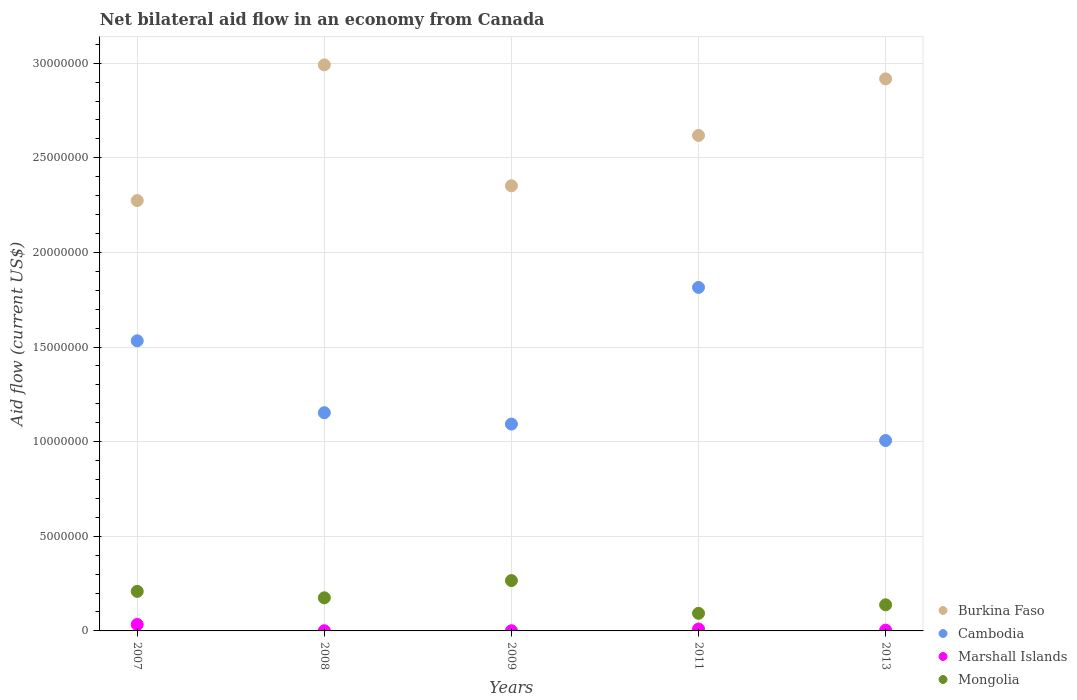What is the net bilateral aid flow in Burkina Faso in 2008?
Offer a very short reply. 2.99e+07. Across all years, what is the minimum net bilateral aid flow in Burkina Faso?
Your answer should be compact. 2.27e+07. In which year was the net bilateral aid flow in Mongolia maximum?
Your answer should be very brief. 2009. In which year was the net bilateral aid flow in Burkina Faso minimum?
Your answer should be compact. 2007. What is the total net bilateral aid flow in Marshall Islands in the graph?
Keep it short and to the point. 5.00e+05. What is the difference between the net bilateral aid flow in Marshall Islands in 2009 and that in 2013?
Give a very brief answer. -3.00e+04. What is the difference between the net bilateral aid flow in Cambodia in 2013 and the net bilateral aid flow in Mongolia in 2008?
Give a very brief answer. 8.31e+06. What is the average net bilateral aid flow in Cambodia per year?
Provide a succinct answer. 1.32e+07. In the year 2011, what is the difference between the net bilateral aid flow in Mongolia and net bilateral aid flow in Burkina Faso?
Your response must be concise. -2.52e+07. Is the net bilateral aid flow in Burkina Faso in 2007 less than that in 2009?
Keep it short and to the point. Yes. What is the difference between the highest and the second highest net bilateral aid flow in Mongolia?
Make the answer very short. 5.70e+05. What is the difference between the highest and the lowest net bilateral aid flow in Cambodia?
Make the answer very short. 8.09e+06. Is it the case that in every year, the sum of the net bilateral aid flow in Cambodia and net bilateral aid flow in Burkina Faso  is greater than the net bilateral aid flow in Marshall Islands?
Your answer should be compact. Yes. Does the net bilateral aid flow in Burkina Faso monotonically increase over the years?
Provide a succinct answer. No. How many dotlines are there?
Offer a very short reply. 4. How many years are there in the graph?
Make the answer very short. 5. Are the values on the major ticks of Y-axis written in scientific E-notation?
Provide a succinct answer. No. Where does the legend appear in the graph?
Your answer should be very brief. Bottom right. How many legend labels are there?
Your response must be concise. 4. How are the legend labels stacked?
Keep it short and to the point. Vertical. What is the title of the graph?
Provide a succinct answer. Net bilateral aid flow in an economy from Canada. Does "Bahamas" appear as one of the legend labels in the graph?
Your answer should be compact. No. What is the Aid flow (current US$) in Burkina Faso in 2007?
Keep it short and to the point. 2.27e+07. What is the Aid flow (current US$) of Cambodia in 2007?
Your answer should be compact. 1.53e+07. What is the Aid flow (current US$) in Mongolia in 2007?
Make the answer very short. 2.09e+06. What is the Aid flow (current US$) of Burkina Faso in 2008?
Offer a terse response. 2.99e+07. What is the Aid flow (current US$) in Cambodia in 2008?
Give a very brief answer. 1.15e+07. What is the Aid flow (current US$) in Marshall Islands in 2008?
Your response must be concise. 10000. What is the Aid flow (current US$) of Mongolia in 2008?
Offer a very short reply. 1.75e+06. What is the Aid flow (current US$) of Burkina Faso in 2009?
Offer a very short reply. 2.35e+07. What is the Aid flow (current US$) in Cambodia in 2009?
Your answer should be very brief. 1.09e+07. What is the Aid flow (current US$) of Mongolia in 2009?
Your answer should be very brief. 2.66e+06. What is the Aid flow (current US$) in Burkina Faso in 2011?
Offer a very short reply. 2.62e+07. What is the Aid flow (current US$) in Cambodia in 2011?
Offer a very short reply. 1.82e+07. What is the Aid flow (current US$) of Mongolia in 2011?
Provide a short and direct response. 9.30e+05. What is the Aid flow (current US$) of Burkina Faso in 2013?
Provide a succinct answer. 2.92e+07. What is the Aid flow (current US$) of Cambodia in 2013?
Ensure brevity in your answer.  1.01e+07. What is the Aid flow (current US$) of Marshall Islands in 2013?
Keep it short and to the point. 4.00e+04. What is the Aid flow (current US$) in Mongolia in 2013?
Offer a terse response. 1.38e+06. Across all years, what is the maximum Aid flow (current US$) of Burkina Faso?
Offer a terse response. 2.99e+07. Across all years, what is the maximum Aid flow (current US$) of Cambodia?
Give a very brief answer. 1.82e+07. Across all years, what is the maximum Aid flow (current US$) of Mongolia?
Provide a short and direct response. 2.66e+06. Across all years, what is the minimum Aid flow (current US$) in Burkina Faso?
Make the answer very short. 2.27e+07. Across all years, what is the minimum Aid flow (current US$) of Cambodia?
Your answer should be very brief. 1.01e+07. Across all years, what is the minimum Aid flow (current US$) of Marshall Islands?
Offer a very short reply. 10000. Across all years, what is the minimum Aid flow (current US$) of Mongolia?
Offer a very short reply. 9.30e+05. What is the total Aid flow (current US$) in Burkina Faso in the graph?
Your answer should be very brief. 1.32e+08. What is the total Aid flow (current US$) in Cambodia in the graph?
Your answer should be compact. 6.60e+07. What is the total Aid flow (current US$) of Mongolia in the graph?
Provide a succinct answer. 8.81e+06. What is the difference between the Aid flow (current US$) of Burkina Faso in 2007 and that in 2008?
Your response must be concise. -7.17e+06. What is the difference between the Aid flow (current US$) in Cambodia in 2007 and that in 2008?
Ensure brevity in your answer.  3.80e+06. What is the difference between the Aid flow (current US$) of Marshall Islands in 2007 and that in 2008?
Make the answer very short. 3.30e+05. What is the difference between the Aid flow (current US$) of Burkina Faso in 2007 and that in 2009?
Give a very brief answer. -7.80e+05. What is the difference between the Aid flow (current US$) of Cambodia in 2007 and that in 2009?
Provide a succinct answer. 4.40e+06. What is the difference between the Aid flow (current US$) in Mongolia in 2007 and that in 2009?
Make the answer very short. -5.70e+05. What is the difference between the Aid flow (current US$) of Burkina Faso in 2007 and that in 2011?
Your response must be concise. -3.44e+06. What is the difference between the Aid flow (current US$) of Cambodia in 2007 and that in 2011?
Your answer should be very brief. -2.82e+06. What is the difference between the Aid flow (current US$) of Marshall Islands in 2007 and that in 2011?
Provide a short and direct response. 2.40e+05. What is the difference between the Aid flow (current US$) in Mongolia in 2007 and that in 2011?
Give a very brief answer. 1.16e+06. What is the difference between the Aid flow (current US$) of Burkina Faso in 2007 and that in 2013?
Offer a very short reply. -6.43e+06. What is the difference between the Aid flow (current US$) in Cambodia in 2007 and that in 2013?
Offer a very short reply. 5.27e+06. What is the difference between the Aid flow (current US$) of Mongolia in 2007 and that in 2013?
Your answer should be very brief. 7.10e+05. What is the difference between the Aid flow (current US$) of Burkina Faso in 2008 and that in 2009?
Provide a short and direct response. 6.39e+06. What is the difference between the Aid flow (current US$) in Marshall Islands in 2008 and that in 2009?
Offer a terse response. 0. What is the difference between the Aid flow (current US$) in Mongolia in 2008 and that in 2009?
Give a very brief answer. -9.10e+05. What is the difference between the Aid flow (current US$) of Burkina Faso in 2008 and that in 2011?
Provide a short and direct response. 3.73e+06. What is the difference between the Aid flow (current US$) in Cambodia in 2008 and that in 2011?
Your answer should be compact. -6.62e+06. What is the difference between the Aid flow (current US$) in Mongolia in 2008 and that in 2011?
Your response must be concise. 8.20e+05. What is the difference between the Aid flow (current US$) in Burkina Faso in 2008 and that in 2013?
Offer a very short reply. 7.40e+05. What is the difference between the Aid flow (current US$) of Cambodia in 2008 and that in 2013?
Make the answer very short. 1.47e+06. What is the difference between the Aid flow (current US$) of Mongolia in 2008 and that in 2013?
Keep it short and to the point. 3.70e+05. What is the difference between the Aid flow (current US$) of Burkina Faso in 2009 and that in 2011?
Make the answer very short. -2.66e+06. What is the difference between the Aid flow (current US$) in Cambodia in 2009 and that in 2011?
Provide a short and direct response. -7.22e+06. What is the difference between the Aid flow (current US$) in Marshall Islands in 2009 and that in 2011?
Your answer should be very brief. -9.00e+04. What is the difference between the Aid flow (current US$) in Mongolia in 2009 and that in 2011?
Offer a very short reply. 1.73e+06. What is the difference between the Aid flow (current US$) of Burkina Faso in 2009 and that in 2013?
Give a very brief answer. -5.65e+06. What is the difference between the Aid flow (current US$) in Cambodia in 2009 and that in 2013?
Your answer should be very brief. 8.70e+05. What is the difference between the Aid flow (current US$) of Mongolia in 2009 and that in 2013?
Make the answer very short. 1.28e+06. What is the difference between the Aid flow (current US$) in Burkina Faso in 2011 and that in 2013?
Make the answer very short. -2.99e+06. What is the difference between the Aid flow (current US$) of Cambodia in 2011 and that in 2013?
Offer a very short reply. 8.09e+06. What is the difference between the Aid flow (current US$) in Mongolia in 2011 and that in 2013?
Provide a short and direct response. -4.50e+05. What is the difference between the Aid flow (current US$) of Burkina Faso in 2007 and the Aid flow (current US$) of Cambodia in 2008?
Your answer should be very brief. 1.12e+07. What is the difference between the Aid flow (current US$) in Burkina Faso in 2007 and the Aid flow (current US$) in Marshall Islands in 2008?
Your response must be concise. 2.27e+07. What is the difference between the Aid flow (current US$) in Burkina Faso in 2007 and the Aid flow (current US$) in Mongolia in 2008?
Your answer should be very brief. 2.10e+07. What is the difference between the Aid flow (current US$) in Cambodia in 2007 and the Aid flow (current US$) in Marshall Islands in 2008?
Give a very brief answer. 1.53e+07. What is the difference between the Aid flow (current US$) in Cambodia in 2007 and the Aid flow (current US$) in Mongolia in 2008?
Your response must be concise. 1.36e+07. What is the difference between the Aid flow (current US$) of Marshall Islands in 2007 and the Aid flow (current US$) of Mongolia in 2008?
Your response must be concise. -1.41e+06. What is the difference between the Aid flow (current US$) in Burkina Faso in 2007 and the Aid flow (current US$) in Cambodia in 2009?
Your answer should be compact. 1.18e+07. What is the difference between the Aid flow (current US$) of Burkina Faso in 2007 and the Aid flow (current US$) of Marshall Islands in 2009?
Offer a very short reply. 2.27e+07. What is the difference between the Aid flow (current US$) in Burkina Faso in 2007 and the Aid flow (current US$) in Mongolia in 2009?
Make the answer very short. 2.01e+07. What is the difference between the Aid flow (current US$) of Cambodia in 2007 and the Aid flow (current US$) of Marshall Islands in 2009?
Give a very brief answer. 1.53e+07. What is the difference between the Aid flow (current US$) in Cambodia in 2007 and the Aid flow (current US$) in Mongolia in 2009?
Your response must be concise. 1.27e+07. What is the difference between the Aid flow (current US$) of Marshall Islands in 2007 and the Aid flow (current US$) of Mongolia in 2009?
Provide a short and direct response. -2.32e+06. What is the difference between the Aid flow (current US$) in Burkina Faso in 2007 and the Aid flow (current US$) in Cambodia in 2011?
Your answer should be very brief. 4.59e+06. What is the difference between the Aid flow (current US$) of Burkina Faso in 2007 and the Aid flow (current US$) of Marshall Islands in 2011?
Give a very brief answer. 2.26e+07. What is the difference between the Aid flow (current US$) of Burkina Faso in 2007 and the Aid flow (current US$) of Mongolia in 2011?
Offer a terse response. 2.18e+07. What is the difference between the Aid flow (current US$) in Cambodia in 2007 and the Aid flow (current US$) in Marshall Islands in 2011?
Provide a succinct answer. 1.52e+07. What is the difference between the Aid flow (current US$) in Cambodia in 2007 and the Aid flow (current US$) in Mongolia in 2011?
Keep it short and to the point. 1.44e+07. What is the difference between the Aid flow (current US$) in Marshall Islands in 2007 and the Aid flow (current US$) in Mongolia in 2011?
Your answer should be very brief. -5.90e+05. What is the difference between the Aid flow (current US$) of Burkina Faso in 2007 and the Aid flow (current US$) of Cambodia in 2013?
Your answer should be very brief. 1.27e+07. What is the difference between the Aid flow (current US$) in Burkina Faso in 2007 and the Aid flow (current US$) in Marshall Islands in 2013?
Ensure brevity in your answer.  2.27e+07. What is the difference between the Aid flow (current US$) in Burkina Faso in 2007 and the Aid flow (current US$) in Mongolia in 2013?
Give a very brief answer. 2.14e+07. What is the difference between the Aid flow (current US$) of Cambodia in 2007 and the Aid flow (current US$) of Marshall Islands in 2013?
Your response must be concise. 1.53e+07. What is the difference between the Aid flow (current US$) of Cambodia in 2007 and the Aid flow (current US$) of Mongolia in 2013?
Make the answer very short. 1.40e+07. What is the difference between the Aid flow (current US$) of Marshall Islands in 2007 and the Aid flow (current US$) of Mongolia in 2013?
Your answer should be compact. -1.04e+06. What is the difference between the Aid flow (current US$) of Burkina Faso in 2008 and the Aid flow (current US$) of Cambodia in 2009?
Your answer should be very brief. 1.90e+07. What is the difference between the Aid flow (current US$) in Burkina Faso in 2008 and the Aid flow (current US$) in Marshall Islands in 2009?
Provide a short and direct response. 2.99e+07. What is the difference between the Aid flow (current US$) in Burkina Faso in 2008 and the Aid flow (current US$) in Mongolia in 2009?
Your answer should be very brief. 2.72e+07. What is the difference between the Aid flow (current US$) of Cambodia in 2008 and the Aid flow (current US$) of Marshall Islands in 2009?
Your answer should be compact. 1.15e+07. What is the difference between the Aid flow (current US$) of Cambodia in 2008 and the Aid flow (current US$) of Mongolia in 2009?
Provide a short and direct response. 8.87e+06. What is the difference between the Aid flow (current US$) in Marshall Islands in 2008 and the Aid flow (current US$) in Mongolia in 2009?
Keep it short and to the point. -2.65e+06. What is the difference between the Aid flow (current US$) of Burkina Faso in 2008 and the Aid flow (current US$) of Cambodia in 2011?
Give a very brief answer. 1.18e+07. What is the difference between the Aid flow (current US$) of Burkina Faso in 2008 and the Aid flow (current US$) of Marshall Islands in 2011?
Ensure brevity in your answer.  2.98e+07. What is the difference between the Aid flow (current US$) of Burkina Faso in 2008 and the Aid flow (current US$) of Mongolia in 2011?
Keep it short and to the point. 2.90e+07. What is the difference between the Aid flow (current US$) in Cambodia in 2008 and the Aid flow (current US$) in Marshall Islands in 2011?
Provide a succinct answer. 1.14e+07. What is the difference between the Aid flow (current US$) in Cambodia in 2008 and the Aid flow (current US$) in Mongolia in 2011?
Offer a very short reply. 1.06e+07. What is the difference between the Aid flow (current US$) of Marshall Islands in 2008 and the Aid flow (current US$) of Mongolia in 2011?
Give a very brief answer. -9.20e+05. What is the difference between the Aid flow (current US$) of Burkina Faso in 2008 and the Aid flow (current US$) of Cambodia in 2013?
Offer a terse response. 1.98e+07. What is the difference between the Aid flow (current US$) of Burkina Faso in 2008 and the Aid flow (current US$) of Marshall Islands in 2013?
Your answer should be very brief. 2.99e+07. What is the difference between the Aid flow (current US$) in Burkina Faso in 2008 and the Aid flow (current US$) in Mongolia in 2013?
Make the answer very short. 2.85e+07. What is the difference between the Aid flow (current US$) in Cambodia in 2008 and the Aid flow (current US$) in Marshall Islands in 2013?
Your answer should be very brief. 1.15e+07. What is the difference between the Aid flow (current US$) of Cambodia in 2008 and the Aid flow (current US$) of Mongolia in 2013?
Make the answer very short. 1.02e+07. What is the difference between the Aid flow (current US$) of Marshall Islands in 2008 and the Aid flow (current US$) of Mongolia in 2013?
Ensure brevity in your answer.  -1.37e+06. What is the difference between the Aid flow (current US$) in Burkina Faso in 2009 and the Aid flow (current US$) in Cambodia in 2011?
Your answer should be very brief. 5.37e+06. What is the difference between the Aid flow (current US$) of Burkina Faso in 2009 and the Aid flow (current US$) of Marshall Islands in 2011?
Offer a very short reply. 2.34e+07. What is the difference between the Aid flow (current US$) in Burkina Faso in 2009 and the Aid flow (current US$) in Mongolia in 2011?
Offer a very short reply. 2.26e+07. What is the difference between the Aid flow (current US$) of Cambodia in 2009 and the Aid flow (current US$) of Marshall Islands in 2011?
Provide a short and direct response. 1.08e+07. What is the difference between the Aid flow (current US$) of Cambodia in 2009 and the Aid flow (current US$) of Mongolia in 2011?
Ensure brevity in your answer.  1.00e+07. What is the difference between the Aid flow (current US$) in Marshall Islands in 2009 and the Aid flow (current US$) in Mongolia in 2011?
Your answer should be compact. -9.20e+05. What is the difference between the Aid flow (current US$) of Burkina Faso in 2009 and the Aid flow (current US$) of Cambodia in 2013?
Offer a terse response. 1.35e+07. What is the difference between the Aid flow (current US$) in Burkina Faso in 2009 and the Aid flow (current US$) in Marshall Islands in 2013?
Keep it short and to the point. 2.35e+07. What is the difference between the Aid flow (current US$) of Burkina Faso in 2009 and the Aid flow (current US$) of Mongolia in 2013?
Keep it short and to the point. 2.21e+07. What is the difference between the Aid flow (current US$) of Cambodia in 2009 and the Aid flow (current US$) of Marshall Islands in 2013?
Give a very brief answer. 1.09e+07. What is the difference between the Aid flow (current US$) in Cambodia in 2009 and the Aid flow (current US$) in Mongolia in 2013?
Your answer should be compact. 9.55e+06. What is the difference between the Aid flow (current US$) of Marshall Islands in 2009 and the Aid flow (current US$) of Mongolia in 2013?
Your answer should be very brief. -1.37e+06. What is the difference between the Aid flow (current US$) in Burkina Faso in 2011 and the Aid flow (current US$) in Cambodia in 2013?
Keep it short and to the point. 1.61e+07. What is the difference between the Aid flow (current US$) of Burkina Faso in 2011 and the Aid flow (current US$) of Marshall Islands in 2013?
Ensure brevity in your answer.  2.61e+07. What is the difference between the Aid flow (current US$) in Burkina Faso in 2011 and the Aid flow (current US$) in Mongolia in 2013?
Offer a very short reply. 2.48e+07. What is the difference between the Aid flow (current US$) in Cambodia in 2011 and the Aid flow (current US$) in Marshall Islands in 2013?
Provide a short and direct response. 1.81e+07. What is the difference between the Aid flow (current US$) of Cambodia in 2011 and the Aid flow (current US$) of Mongolia in 2013?
Keep it short and to the point. 1.68e+07. What is the difference between the Aid flow (current US$) of Marshall Islands in 2011 and the Aid flow (current US$) of Mongolia in 2013?
Keep it short and to the point. -1.28e+06. What is the average Aid flow (current US$) of Burkina Faso per year?
Make the answer very short. 2.63e+07. What is the average Aid flow (current US$) of Cambodia per year?
Your response must be concise. 1.32e+07. What is the average Aid flow (current US$) of Marshall Islands per year?
Offer a terse response. 1.00e+05. What is the average Aid flow (current US$) of Mongolia per year?
Keep it short and to the point. 1.76e+06. In the year 2007, what is the difference between the Aid flow (current US$) of Burkina Faso and Aid flow (current US$) of Cambodia?
Make the answer very short. 7.41e+06. In the year 2007, what is the difference between the Aid flow (current US$) in Burkina Faso and Aid flow (current US$) in Marshall Islands?
Provide a succinct answer. 2.24e+07. In the year 2007, what is the difference between the Aid flow (current US$) of Burkina Faso and Aid flow (current US$) of Mongolia?
Make the answer very short. 2.06e+07. In the year 2007, what is the difference between the Aid flow (current US$) of Cambodia and Aid flow (current US$) of Marshall Islands?
Provide a succinct answer. 1.50e+07. In the year 2007, what is the difference between the Aid flow (current US$) in Cambodia and Aid flow (current US$) in Mongolia?
Offer a very short reply. 1.32e+07. In the year 2007, what is the difference between the Aid flow (current US$) of Marshall Islands and Aid flow (current US$) of Mongolia?
Your answer should be compact. -1.75e+06. In the year 2008, what is the difference between the Aid flow (current US$) in Burkina Faso and Aid flow (current US$) in Cambodia?
Give a very brief answer. 1.84e+07. In the year 2008, what is the difference between the Aid flow (current US$) in Burkina Faso and Aid flow (current US$) in Marshall Islands?
Your answer should be very brief. 2.99e+07. In the year 2008, what is the difference between the Aid flow (current US$) of Burkina Faso and Aid flow (current US$) of Mongolia?
Keep it short and to the point. 2.82e+07. In the year 2008, what is the difference between the Aid flow (current US$) in Cambodia and Aid flow (current US$) in Marshall Islands?
Keep it short and to the point. 1.15e+07. In the year 2008, what is the difference between the Aid flow (current US$) of Cambodia and Aid flow (current US$) of Mongolia?
Your response must be concise. 9.78e+06. In the year 2008, what is the difference between the Aid flow (current US$) in Marshall Islands and Aid flow (current US$) in Mongolia?
Make the answer very short. -1.74e+06. In the year 2009, what is the difference between the Aid flow (current US$) in Burkina Faso and Aid flow (current US$) in Cambodia?
Make the answer very short. 1.26e+07. In the year 2009, what is the difference between the Aid flow (current US$) of Burkina Faso and Aid flow (current US$) of Marshall Islands?
Offer a very short reply. 2.35e+07. In the year 2009, what is the difference between the Aid flow (current US$) in Burkina Faso and Aid flow (current US$) in Mongolia?
Offer a terse response. 2.09e+07. In the year 2009, what is the difference between the Aid flow (current US$) of Cambodia and Aid flow (current US$) of Marshall Islands?
Keep it short and to the point. 1.09e+07. In the year 2009, what is the difference between the Aid flow (current US$) of Cambodia and Aid flow (current US$) of Mongolia?
Make the answer very short. 8.27e+06. In the year 2009, what is the difference between the Aid flow (current US$) of Marshall Islands and Aid flow (current US$) of Mongolia?
Your answer should be very brief. -2.65e+06. In the year 2011, what is the difference between the Aid flow (current US$) of Burkina Faso and Aid flow (current US$) of Cambodia?
Offer a terse response. 8.03e+06. In the year 2011, what is the difference between the Aid flow (current US$) of Burkina Faso and Aid flow (current US$) of Marshall Islands?
Your response must be concise. 2.61e+07. In the year 2011, what is the difference between the Aid flow (current US$) of Burkina Faso and Aid flow (current US$) of Mongolia?
Offer a very short reply. 2.52e+07. In the year 2011, what is the difference between the Aid flow (current US$) in Cambodia and Aid flow (current US$) in Marshall Islands?
Offer a terse response. 1.80e+07. In the year 2011, what is the difference between the Aid flow (current US$) in Cambodia and Aid flow (current US$) in Mongolia?
Offer a very short reply. 1.72e+07. In the year 2011, what is the difference between the Aid flow (current US$) in Marshall Islands and Aid flow (current US$) in Mongolia?
Ensure brevity in your answer.  -8.30e+05. In the year 2013, what is the difference between the Aid flow (current US$) in Burkina Faso and Aid flow (current US$) in Cambodia?
Offer a very short reply. 1.91e+07. In the year 2013, what is the difference between the Aid flow (current US$) in Burkina Faso and Aid flow (current US$) in Marshall Islands?
Provide a short and direct response. 2.91e+07. In the year 2013, what is the difference between the Aid flow (current US$) in Burkina Faso and Aid flow (current US$) in Mongolia?
Keep it short and to the point. 2.78e+07. In the year 2013, what is the difference between the Aid flow (current US$) in Cambodia and Aid flow (current US$) in Marshall Islands?
Offer a terse response. 1.00e+07. In the year 2013, what is the difference between the Aid flow (current US$) in Cambodia and Aid flow (current US$) in Mongolia?
Keep it short and to the point. 8.68e+06. In the year 2013, what is the difference between the Aid flow (current US$) of Marshall Islands and Aid flow (current US$) of Mongolia?
Provide a succinct answer. -1.34e+06. What is the ratio of the Aid flow (current US$) of Burkina Faso in 2007 to that in 2008?
Give a very brief answer. 0.76. What is the ratio of the Aid flow (current US$) in Cambodia in 2007 to that in 2008?
Ensure brevity in your answer.  1.33. What is the ratio of the Aid flow (current US$) in Marshall Islands in 2007 to that in 2008?
Offer a very short reply. 34. What is the ratio of the Aid flow (current US$) in Mongolia in 2007 to that in 2008?
Your answer should be compact. 1.19. What is the ratio of the Aid flow (current US$) of Burkina Faso in 2007 to that in 2009?
Provide a succinct answer. 0.97. What is the ratio of the Aid flow (current US$) in Cambodia in 2007 to that in 2009?
Provide a short and direct response. 1.4. What is the ratio of the Aid flow (current US$) of Mongolia in 2007 to that in 2009?
Offer a terse response. 0.79. What is the ratio of the Aid flow (current US$) in Burkina Faso in 2007 to that in 2011?
Your answer should be very brief. 0.87. What is the ratio of the Aid flow (current US$) of Cambodia in 2007 to that in 2011?
Offer a terse response. 0.84. What is the ratio of the Aid flow (current US$) in Marshall Islands in 2007 to that in 2011?
Provide a short and direct response. 3.4. What is the ratio of the Aid flow (current US$) in Mongolia in 2007 to that in 2011?
Your answer should be very brief. 2.25. What is the ratio of the Aid flow (current US$) of Burkina Faso in 2007 to that in 2013?
Give a very brief answer. 0.78. What is the ratio of the Aid flow (current US$) in Cambodia in 2007 to that in 2013?
Provide a short and direct response. 1.52. What is the ratio of the Aid flow (current US$) in Mongolia in 2007 to that in 2013?
Make the answer very short. 1.51. What is the ratio of the Aid flow (current US$) in Burkina Faso in 2008 to that in 2009?
Your response must be concise. 1.27. What is the ratio of the Aid flow (current US$) of Cambodia in 2008 to that in 2009?
Offer a terse response. 1.05. What is the ratio of the Aid flow (current US$) of Mongolia in 2008 to that in 2009?
Make the answer very short. 0.66. What is the ratio of the Aid flow (current US$) of Burkina Faso in 2008 to that in 2011?
Provide a succinct answer. 1.14. What is the ratio of the Aid flow (current US$) in Cambodia in 2008 to that in 2011?
Ensure brevity in your answer.  0.64. What is the ratio of the Aid flow (current US$) in Marshall Islands in 2008 to that in 2011?
Make the answer very short. 0.1. What is the ratio of the Aid flow (current US$) of Mongolia in 2008 to that in 2011?
Your response must be concise. 1.88. What is the ratio of the Aid flow (current US$) of Burkina Faso in 2008 to that in 2013?
Make the answer very short. 1.03. What is the ratio of the Aid flow (current US$) in Cambodia in 2008 to that in 2013?
Ensure brevity in your answer.  1.15. What is the ratio of the Aid flow (current US$) in Marshall Islands in 2008 to that in 2013?
Your answer should be compact. 0.25. What is the ratio of the Aid flow (current US$) of Mongolia in 2008 to that in 2013?
Your answer should be compact. 1.27. What is the ratio of the Aid flow (current US$) in Burkina Faso in 2009 to that in 2011?
Provide a short and direct response. 0.9. What is the ratio of the Aid flow (current US$) of Cambodia in 2009 to that in 2011?
Keep it short and to the point. 0.6. What is the ratio of the Aid flow (current US$) of Marshall Islands in 2009 to that in 2011?
Provide a succinct answer. 0.1. What is the ratio of the Aid flow (current US$) in Mongolia in 2009 to that in 2011?
Your response must be concise. 2.86. What is the ratio of the Aid flow (current US$) of Burkina Faso in 2009 to that in 2013?
Your response must be concise. 0.81. What is the ratio of the Aid flow (current US$) in Cambodia in 2009 to that in 2013?
Provide a succinct answer. 1.09. What is the ratio of the Aid flow (current US$) of Marshall Islands in 2009 to that in 2013?
Your answer should be compact. 0.25. What is the ratio of the Aid flow (current US$) of Mongolia in 2009 to that in 2013?
Make the answer very short. 1.93. What is the ratio of the Aid flow (current US$) in Burkina Faso in 2011 to that in 2013?
Offer a very short reply. 0.9. What is the ratio of the Aid flow (current US$) in Cambodia in 2011 to that in 2013?
Give a very brief answer. 1.8. What is the ratio of the Aid flow (current US$) of Marshall Islands in 2011 to that in 2013?
Give a very brief answer. 2.5. What is the ratio of the Aid flow (current US$) in Mongolia in 2011 to that in 2013?
Give a very brief answer. 0.67. What is the difference between the highest and the second highest Aid flow (current US$) of Burkina Faso?
Ensure brevity in your answer.  7.40e+05. What is the difference between the highest and the second highest Aid flow (current US$) of Cambodia?
Your response must be concise. 2.82e+06. What is the difference between the highest and the second highest Aid flow (current US$) in Marshall Islands?
Give a very brief answer. 2.40e+05. What is the difference between the highest and the second highest Aid flow (current US$) in Mongolia?
Keep it short and to the point. 5.70e+05. What is the difference between the highest and the lowest Aid flow (current US$) in Burkina Faso?
Offer a terse response. 7.17e+06. What is the difference between the highest and the lowest Aid flow (current US$) in Cambodia?
Your response must be concise. 8.09e+06. What is the difference between the highest and the lowest Aid flow (current US$) of Mongolia?
Give a very brief answer. 1.73e+06. 